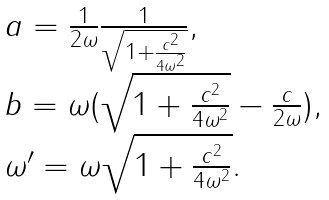Convert formula to latex. <formula><loc_0><loc_0><loc_500><loc_500>\begin{array} { l } a = \frac { 1 } { 2 \omega } \frac { 1 } { \sqrt { 1 + \frac { c ^ { 2 } } { 4 { \omega } ^ { 2 } } } } , \\ b = \omega ( \sqrt { 1 + \frac { c ^ { 2 } } { 4 { \omega } ^ { 2 } } } - \frac { c } { 2 \omega } ) , \\ \omega ^ { \prime } = \omega \sqrt { 1 + \frac { c ^ { 2 } } { 4 { \omega } ^ { 2 } } } . \end{array}</formula> 